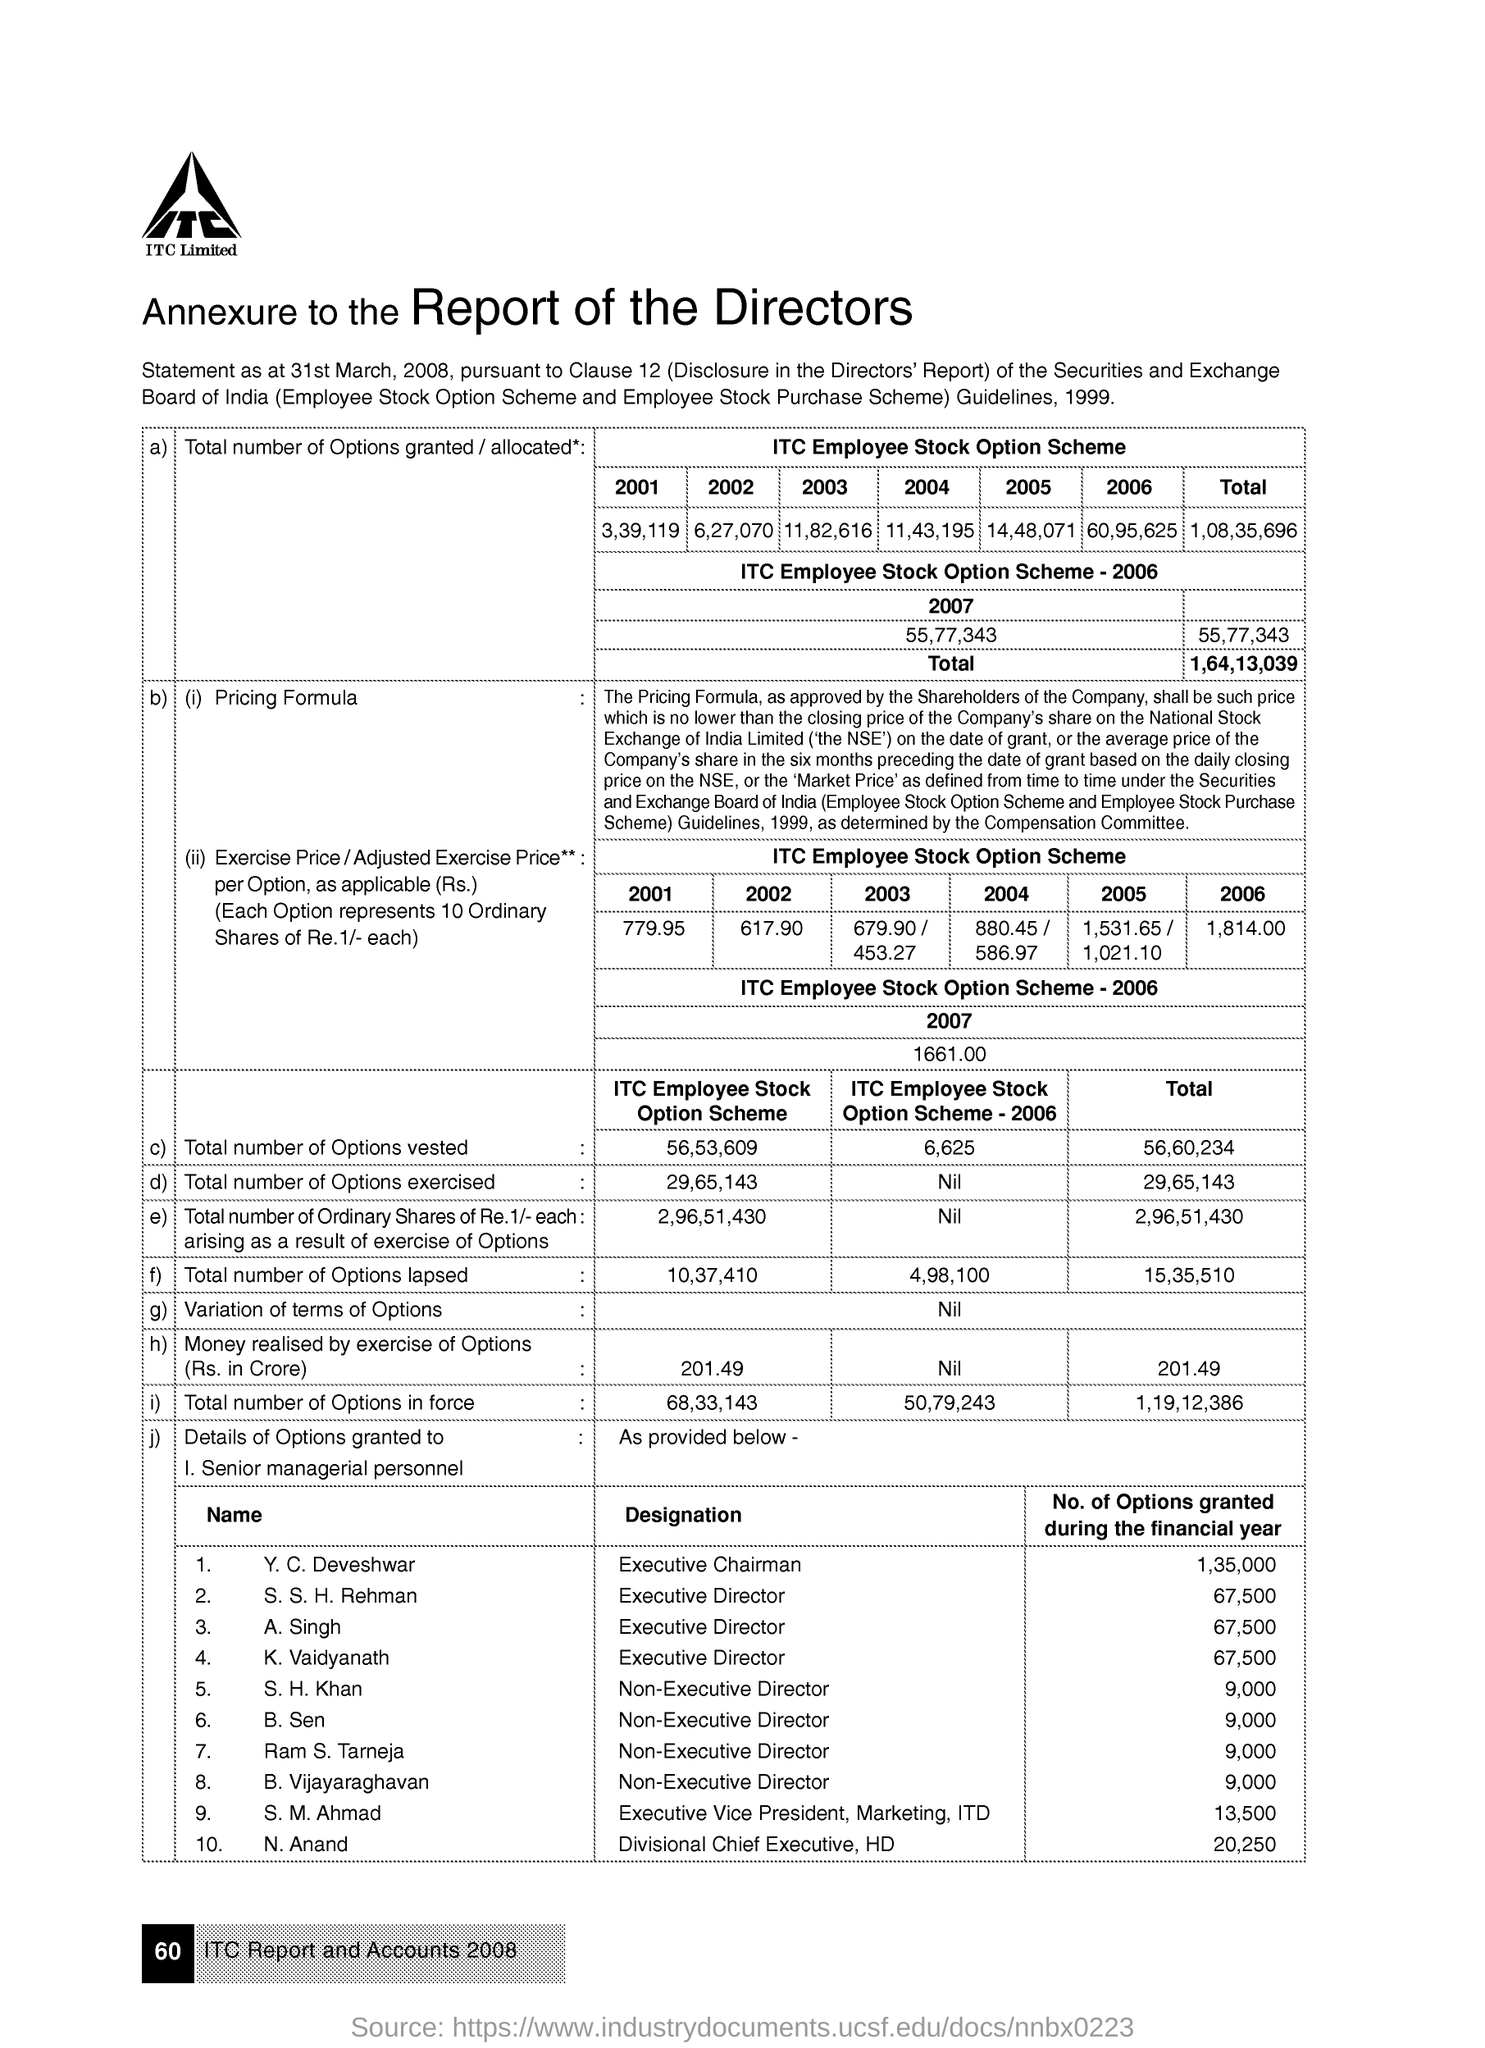Mention a couple of crucial points in this snapshot. The name of the company is ITC Limited. Y.C. Deveshwar is the executive chairman. During the financial year, N Anand was granted a total of 20,250 options. 